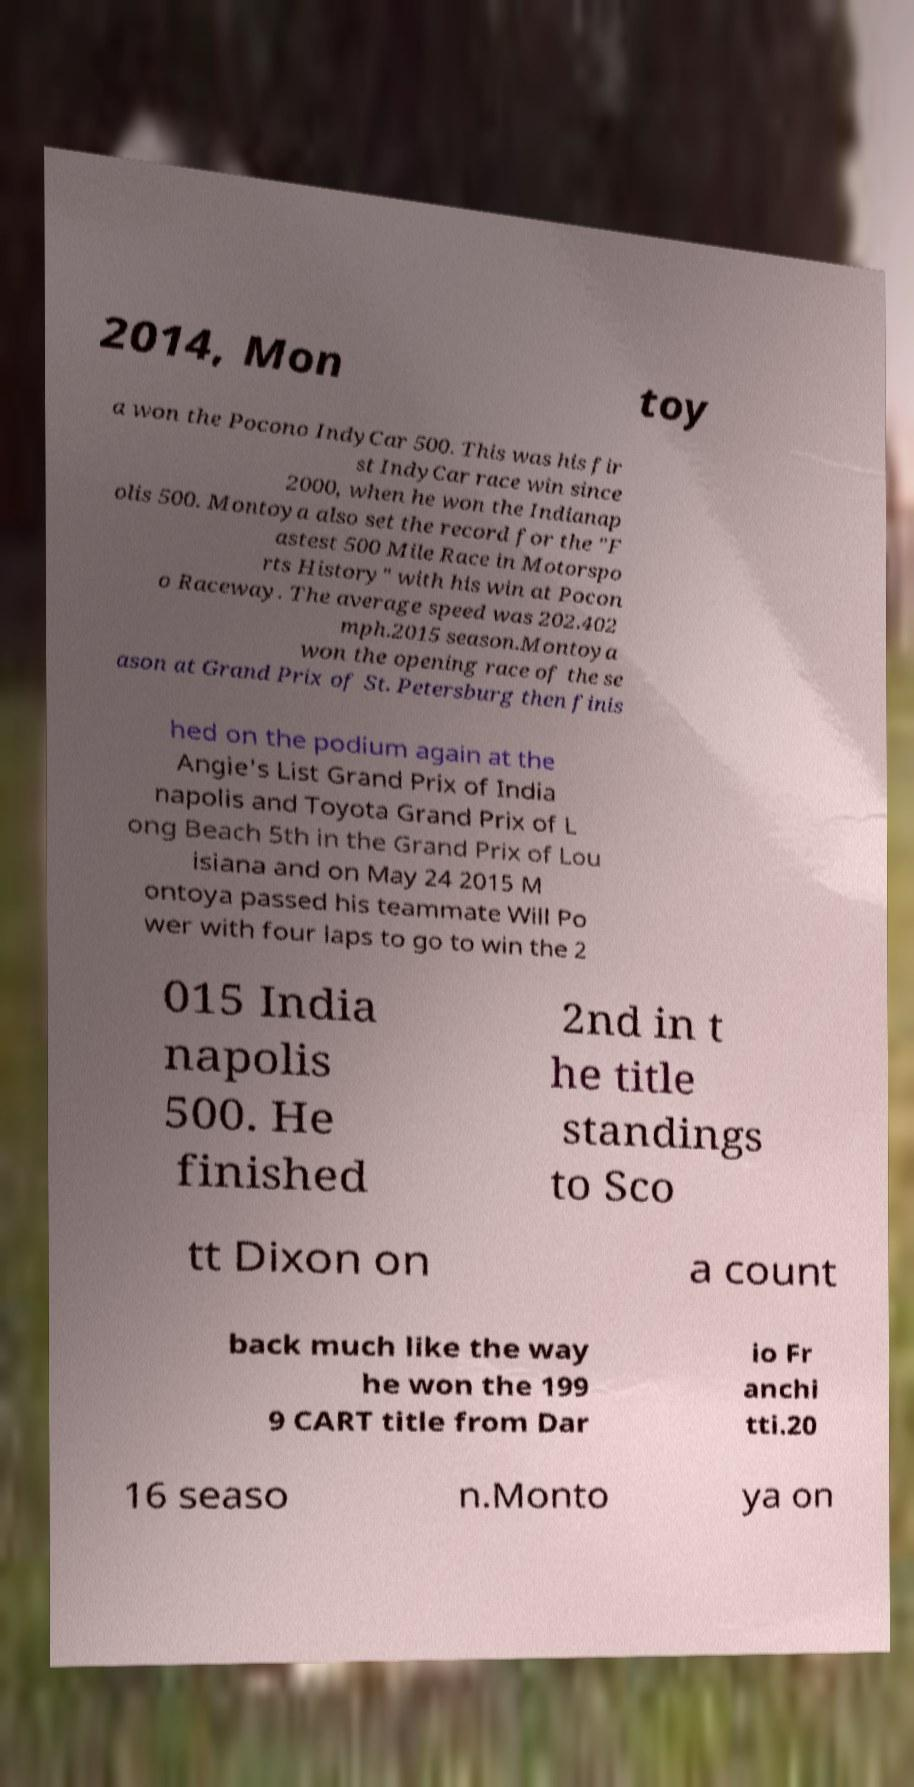I need the written content from this picture converted into text. Can you do that? 2014, Mon toy a won the Pocono IndyCar 500. This was his fir st IndyCar race win since 2000, when he won the Indianap olis 500. Montoya also set the record for the "F astest 500 Mile Race in Motorspo rts History" with his win at Pocon o Raceway. The average speed was 202.402 mph.2015 season.Montoya won the opening race of the se ason at Grand Prix of St. Petersburg then finis hed on the podium again at the Angie's List Grand Prix of India napolis and Toyota Grand Prix of L ong Beach 5th in the Grand Prix of Lou isiana and on May 24 2015 M ontoya passed his teammate Will Po wer with four laps to go to win the 2 015 India napolis 500. He finished 2nd in t he title standings to Sco tt Dixon on a count back much like the way he won the 199 9 CART title from Dar io Fr anchi tti.20 16 seaso n.Monto ya on 